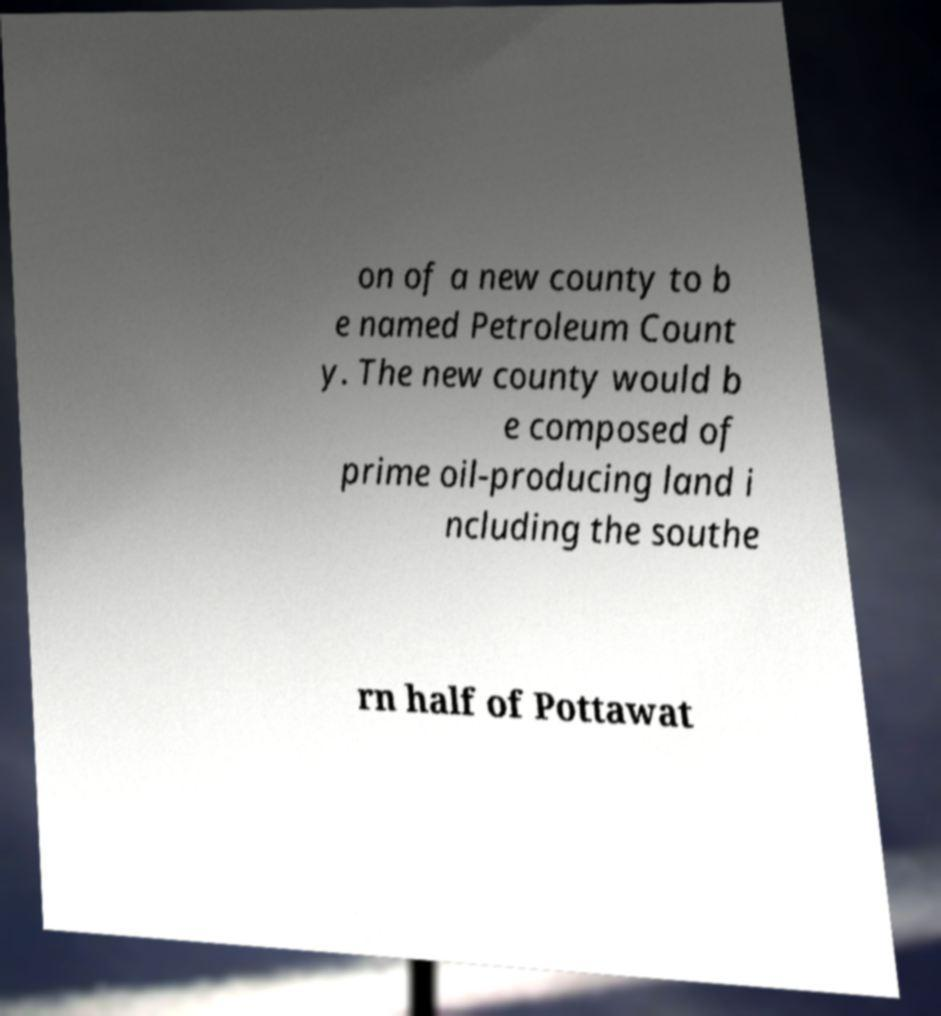Could you extract and type out the text from this image? on of a new county to b e named Petroleum Count y. The new county would b e composed of prime oil-producing land i ncluding the southe rn half of Pottawat 